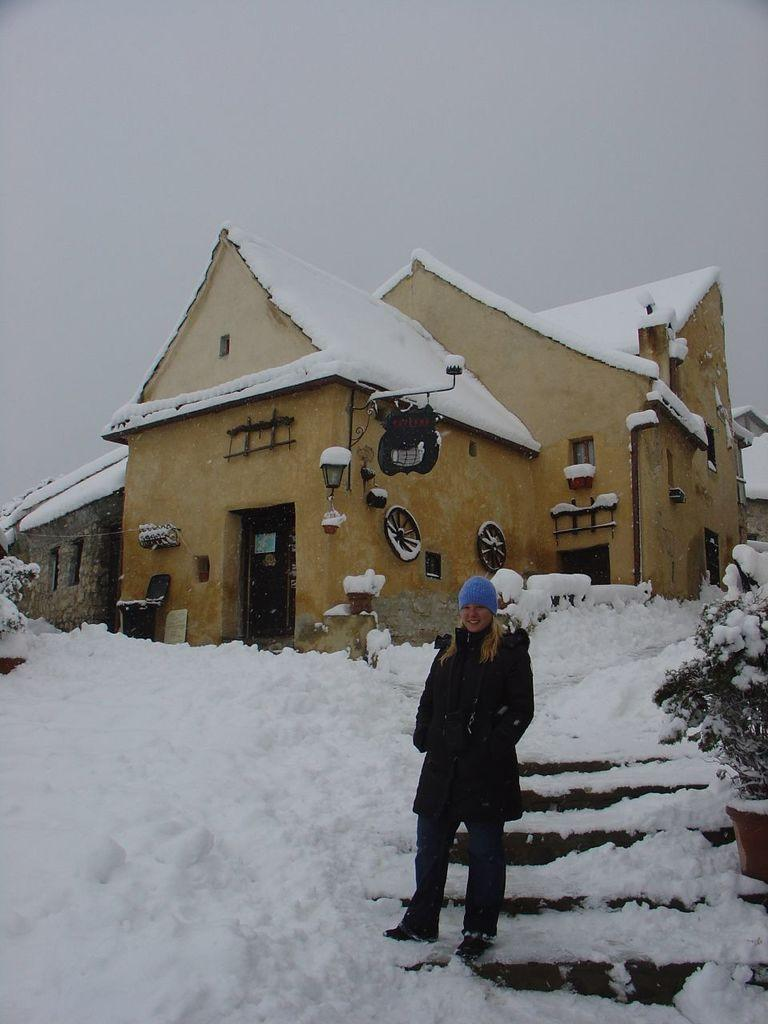What is the man doing in the image? The man is standing in the image. How is the woman dressed in the image? The woman is wearing a black dress and a blue cap. What is the weather like in the image? There is snow visible in the image, indicating a cold or wintery setting. What architectural feature can be seen in the image? There are stairs in the image. What type of vegetation is present in the image? There are plants in the image. What color is the building in the image? The building in the image is cream-colored. What type of can is visible in the image? There is no can present in the image; it features a man standing, a woman wearing a black dress and a blue cap, snow, stairs, plants, and a cream-colored building. What material is the steel used for in the image? There is no steel present in the image. 